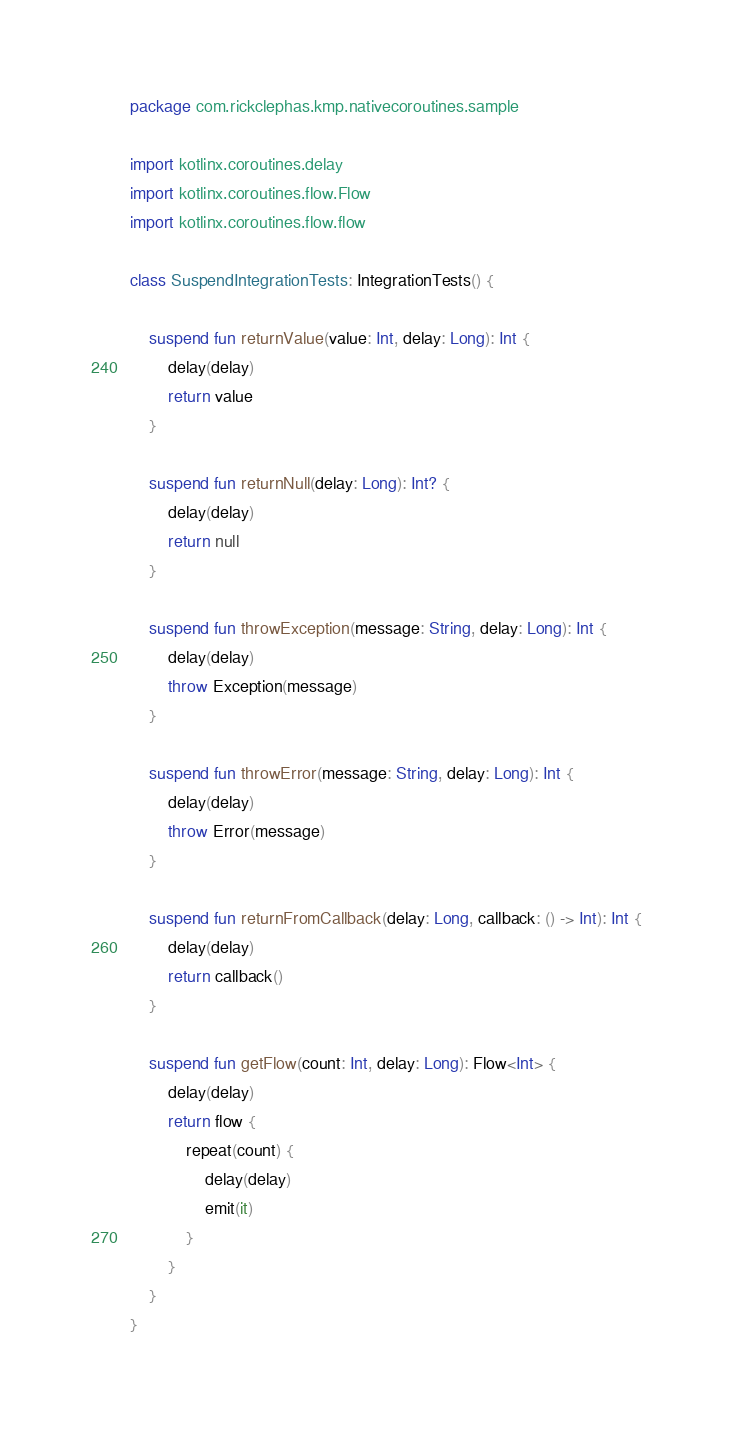Convert code to text. <code><loc_0><loc_0><loc_500><loc_500><_Kotlin_>package com.rickclephas.kmp.nativecoroutines.sample

import kotlinx.coroutines.delay
import kotlinx.coroutines.flow.Flow
import kotlinx.coroutines.flow.flow

class SuspendIntegrationTests: IntegrationTests() {

    suspend fun returnValue(value: Int, delay: Long): Int {
        delay(delay)
        return value
    }

    suspend fun returnNull(delay: Long): Int? {
        delay(delay)
        return null
    }

    suspend fun throwException(message: String, delay: Long): Int {
        delay(delay)
        throw Exception(message)
    }

    suspend fun throwError(message: String, delay: Long): Int {
        delay(delay)
        throw Error(message)
    }

    suspend fun returnFromCallback(delay: Long, callback: () -> Int): Int {
        delay(delay)
        return callback()
    }

    suspend fun getFlow(count: Int, delay: Long): Flow<Int> {
        delay(delay)
        return flow {
            repeat(count) {
                delay(delay)
                emit(it)
            }
        }
    }
}
</code> 